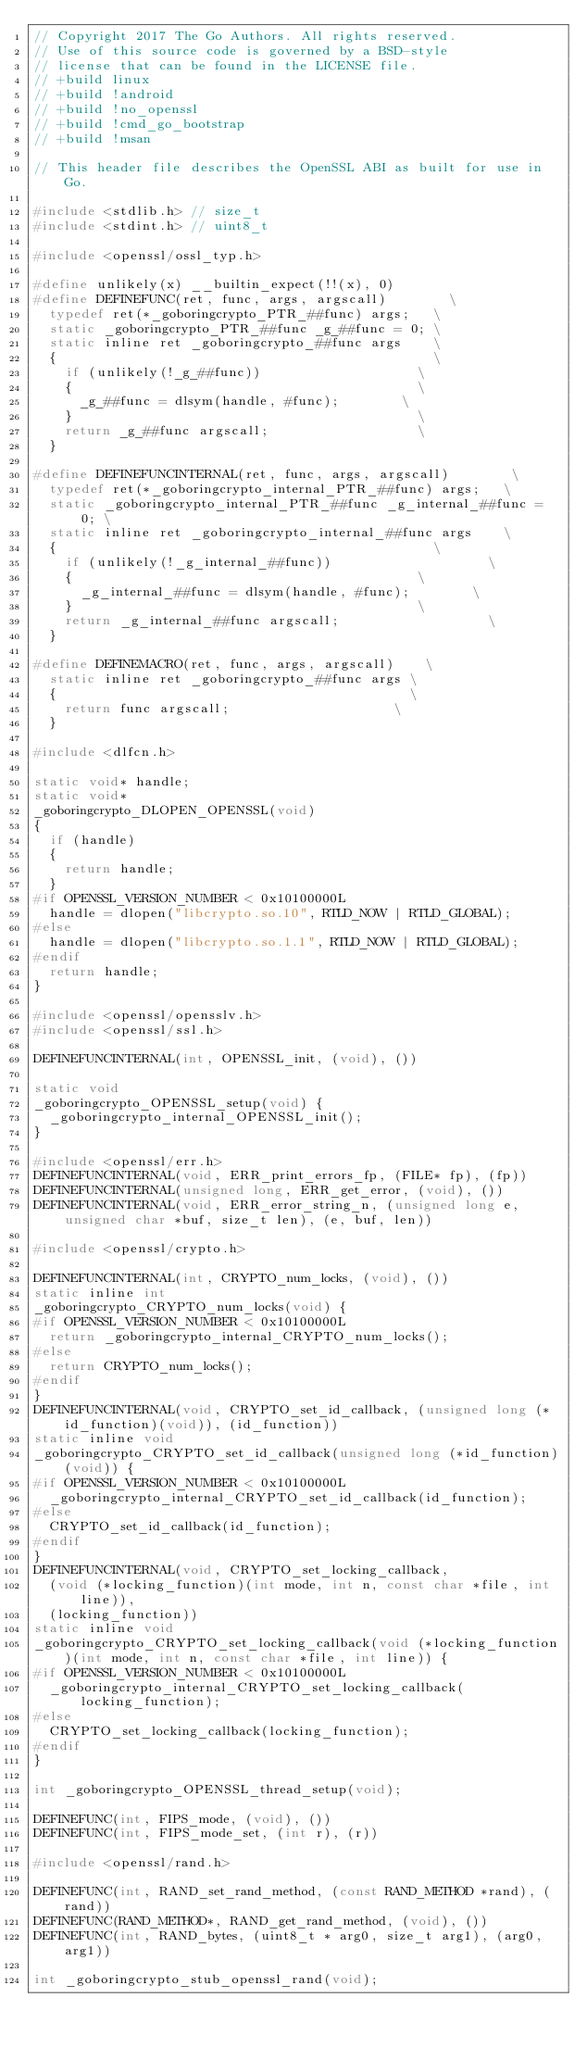Convert code to text. <code><loc_0><loc_0><loc_500><loc_500><_C_>// Copyright 2017 The Go Authors. All rights reserved.
// Use of this source code is governed by a BSD-style
// license that can be found in the LICENSE file.
// +build linux
// +build !android
// +build !no_openssl
// +build !cmd_go_bootstrap
// +build !msan

// This header file describes the OpenSSL ABI as built for use in Go.

#include <stdlib.h> // size_t
#include <stdint.h> // uint8_t

#include <openssl/ossl_typ.h>

#define unlikely(x) __builtin_expect(!!(x), 0)
#define DEFINEFUNC(ret, func, args, argscall)        \
	typedef ret(*_goboringcrypto_PTR_##func) args;   \
	static _goboringcrypto_PTR_##func _g_##func = 0; \
	static inline ret _goboringcrypto_##func args    \
	{                                                \
		if (unlikely(!_g_##func))                    \
		{                                            \
			_g_##func = dlsym(handle, #func);        \
		}                                            \
		return _g_##func argscall;                   \
	}

#define DEFINEFUNCINTERNAL(ret, func, args, argscall)        \
	typedef ret(*_goboringcrypto_internal_PTR_##func) args;   \
	static _goboringcrypto_internal_PTR_##func _g_internal_##func = 0; \
	static inline ret _goboringcrypto_internal_##func args    \
	{                                                \
		if (unlikely(!_g_internal_##func))                    \
		{                                            \
			_g_internal_##func = dlsym(handle, #func);        \
		}                                            \
		return _g_internal_##func argscall;                   \
	}

#define DEFINEMACRO(ret, func, args, argscall)    \
	static inline ret _goboringcrypto_##func args \
	{                                             \
		return func argscall;                     \
	}

#include <dlfcn.h>

static void* handle;
static void*
_goboringcrypto_DLOPEN_OPENSSL(void)
{
	if (handle)
	{
		return handle;
	}
#if OPENSSL_VERSION_NUMBER < 0x10100000L
	handle = dlopen("libcrypto.so.10", RTLD_NOW | RTLD_GLOBAL);
#else
	handle = dlopen("libcrypto.so.1.1", RTLD_NOW | RTLD_GLOBAL);
#endif
	return handle;
}

#include <openssl/opensslv.h>
#include <openssl/ssl.h>

DEFINEFUNCINTERNAL(int, OPENSSL_init, (void), ())

static void
_goboringcrypto_OPENSSL_setup(void) {
	_goboringcrypto_internal_OPENSSL_init();
}

#include <openssl/err.h>
DEFINEFUNCINTERNAL(void, ERR_print_errors_fp, (FILE* fp), (fp))
DEFINEFUNCINTERNAL(unsigned long, ERR_get_error, (void), ())
DEFINEFUNCINTERNAL(void, ERR_error_string_n, (unsigned long e, unsigned char *buf, size_t len), (e, buf, len))

#include <openssl/crypto.h>

DEFINEFUNCINTERNAL(int, CRYPTO_num_locks, (void), ())
static inline int
_goboringcrypto_CRYPTO_num_locks(void) {
#if OPENSSL_VERSION_NUMBER < 0x10100000L
	return _goboringcrypto_internal_CRYPTO_num_locks();
#else
	return CRYPTO_num_locks();
#endif
}
DEFINEFUNCINTERNAL(void, CRYPTO_set_id_callback, (unsigned long (*id_function)(void)), (id_function))
static inline void
_goboringcrypto_CRYPTO_set_id_callback(unsigned long (*id_function)(void)) {
#if OPENSSL_VERSION_NUMBER < 0x10100000L
	_goboringcrypto_internal_CRYPTO_set_id_callback(id_function);
#else
	CRYPTO_set_id_callback(id_function);
#endif
}
DEFINEFUNCINTERNAL(void, CRYPTO_set_locking_callback,
	(void (*locking_function)(int mode, int n, const char *file, int line)), 
	(locking_function))
static inline void
_goboringcrypto_CRYPTO_set_locking_callback(void (*locking_function)(int mode, int n, const char *file, int line)) {
#if OPENSSL_VERSION_NUMBER < 0x10100000L
	_goboringcrypto_internal_CRYPTO_set_locking_callback(locking_function);
#else
	CRYPTO_set_locking_callback(locking_function);
#endif
}

int _goboringcrypto_OPENSSL_thread_setup(void);

DEFINEFUNC(int, FIPS_mode, (void), ())
DEFINEFUNC(int, FIPS_mode_set, (int r), (r))

#include <openssl/rand.h>

DEFINEFUNC(int, RAND_set_rand_method, (const RAND_METHOD *rand), (rand))
DEFINEFUNC(RAND_METHOD*, RAND_get_rand_method, (void), ())
DEFINEFUNC(int, RAND_bytes, (uint8_t * arg0, size_t arg1), (arg0, arg1))

int _goboringcrypto_stub_openssl_rand(void);</code> 